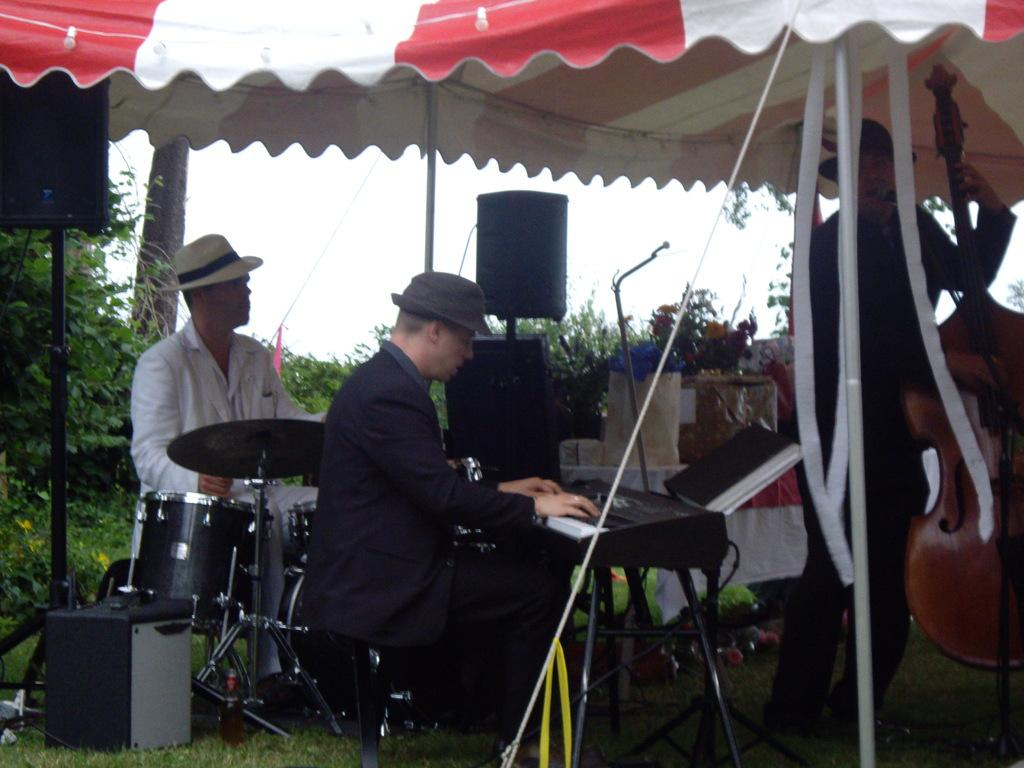How many persons are playing musical instruments in the image? There are three persons playing musical instruments in the image. What type of surface can be seen beneath the persons? There is grass visible in the image. What devices are used for amplifying sound in the image? There are speakers present in the image. What type of vegetation is present in the image? Plants are present in the image. What structures are visible in the image? Poles are visible in the image. What is used for connecting or securing objects in the image? Ropes are present in the image. What device is used for capturing or transmitting sound in the image? A microphone (mike) is visible in the image. What type of shelter is present in the image? There is a tent in the image. What can be seen in the background of the image? The sky is visible in the background. What is the wealth distribution like among the plants in the image? There is no information about wealth distribution in the image, as it features persons playing musical instruments, grass, speakers, plants, poles, ropes, a microphone, a tent, and the sky. How does the brain of the person playing the guitar in the image function? There is no information about the brain function of the person playing the guitar in the image, as it focuses on the visual aspects of the scene. 